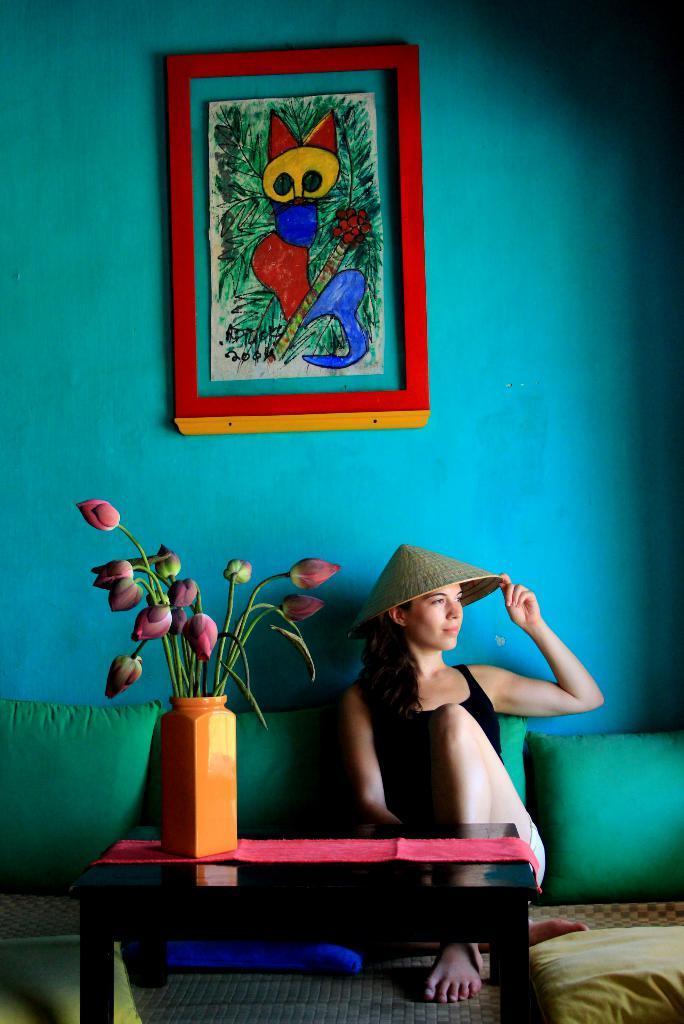Describe this image in one or two sentences. We can see a painting frame over a wall. Here we can see one woman sitting on a sofa. She wore a hat. This is a table and we can see a flower vase on it. 